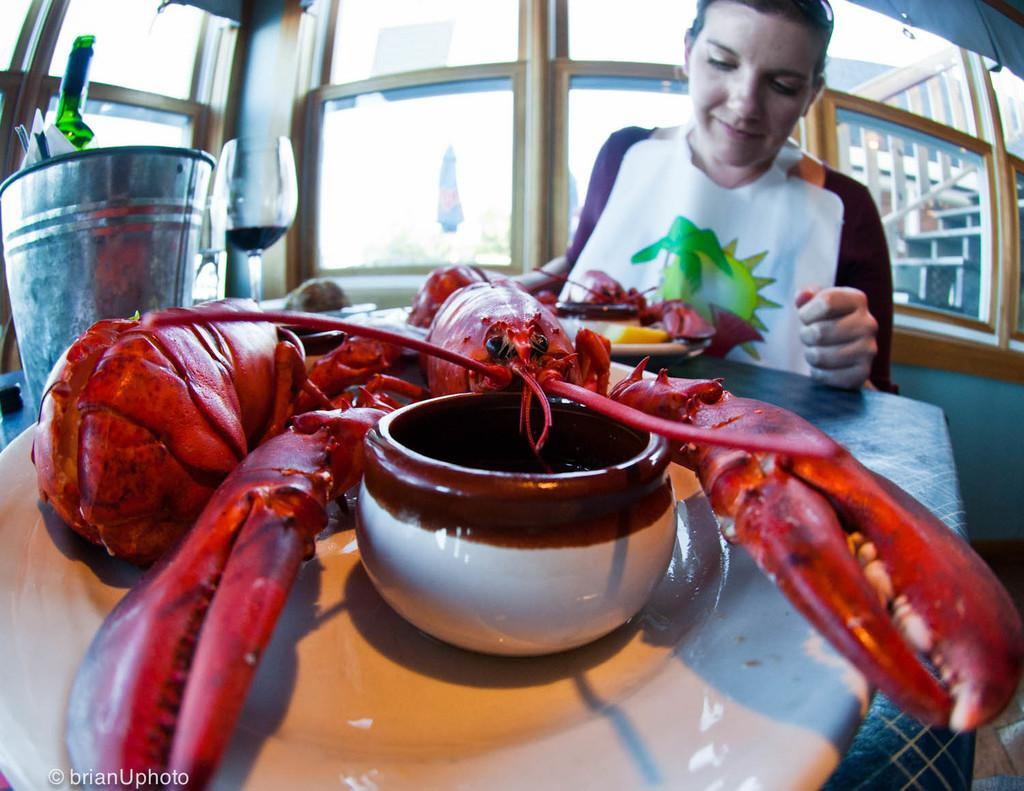What type of animal is in the image? There is a crab in the image. What color is the crab? The crab is red in color. Where is the crab located in the image? The crab is on a white plate. Who is present in the image besides the crab? There is a woman sitting in the image. What can be seen on the left side of the image? There is a wine glass on the left side of the image. What type of twig is the goat holding under the umbrella in the image? There is no goat, twig, or umbrella present in the image. 